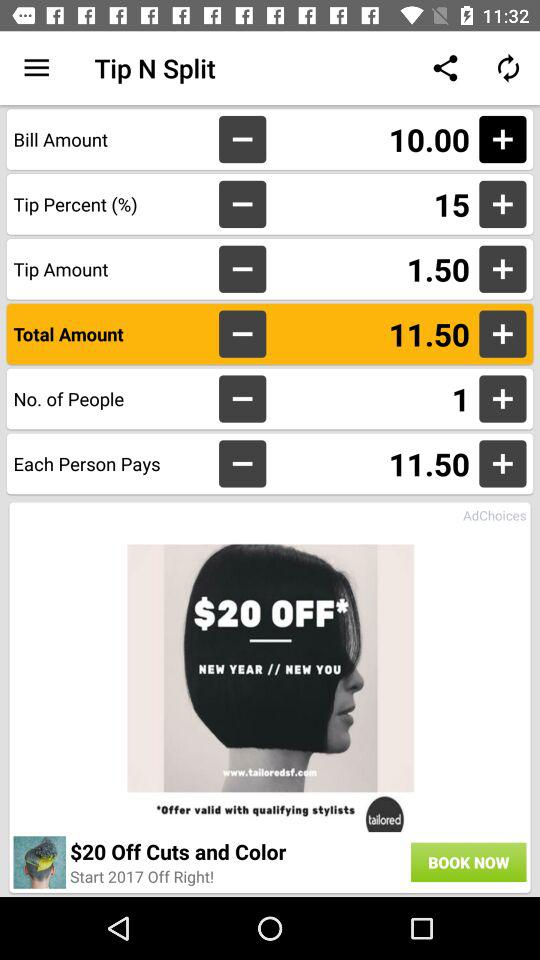What is the total amount? The total amount is 11.50. 